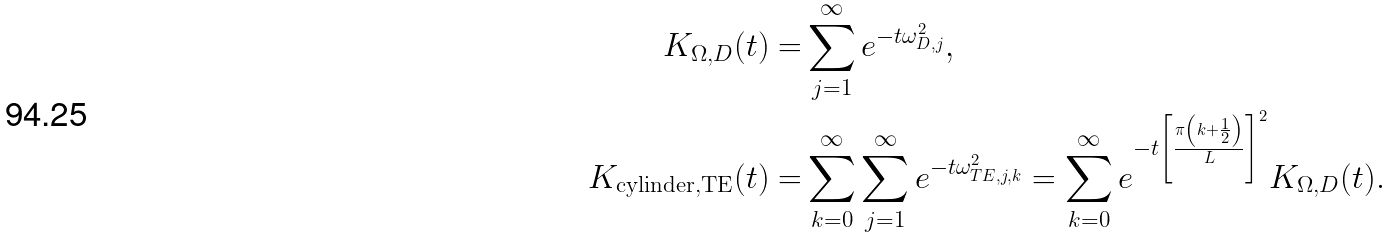<formula> <loc_0><loc_0><loc_500><loc_500>K _ { \Omega , D } ( t ) = & \sum _ { j = 1 } ^ { \infty } e ^ { - t \omega _ { D , j } ^ { 2 } } , \\ K _ { \text {cylinder} , \text {TE} } ( t ) = & \sum _ { k = 0 } ^ { \infty } \sum _ { j = 1 } ^ { \infty } e ^ { - t \omega _ { T E , j , k } ^ { 2 } } = \sum _ { k = 0 } ^ { \infty } e ^ { - t \left [ \frac { \pi \left ( k + \frac { 1 } { 2 } \right ) } { L } \right ] ^ { 2 } } K _ { \Omega , D } ( t ) .</formula> 